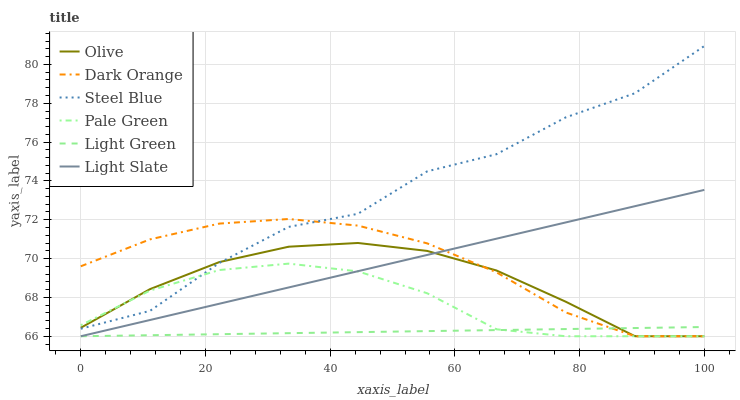Does Light Green have the minimum area under the curve?
Answer yes or no. Yes. Does Steel Blue have the maximum area under the curve?
Answer yes or no. Yes. Does Light Slate have the minimum area under the curve?
Answer yes or no. No. Does Light Slate have the maximum area under the curve?
Answer yes or no. No. Is Light Green the smoothest?
Answer yes or no. Yes. Is Steel Blue the roughest?
Answer yes or no. Yes. Is Light Slate the smoothest?
Answer yes or no. No. Is Light Slate the roughest?
Answer yes or no. No. Does Dark Orange have the lowest value?
Answer yes or no. Yes. Does Steel Blue have the lowest value?
Answer yes or no. No. Does Steel Blue have the highest value?
Answer yes or no. Yes. Does Light Slate have the highest value?
Answer yes or no. No. Is Light Green less than Steel Blue?
Answer yes or no. Yes. Is Steel Blue greater than Light Green?
Answer yes or no. Yes. Does Steel Blue intersect Olive?
Answer yes or no. Yes. Is Steel Blue less than Olive?
Answer yes or no. No. Is Steel Blue greater than Olive?
Answer yes or no. No. Does Light Green intersect Steel Blue?
Answer yes or no. No. 